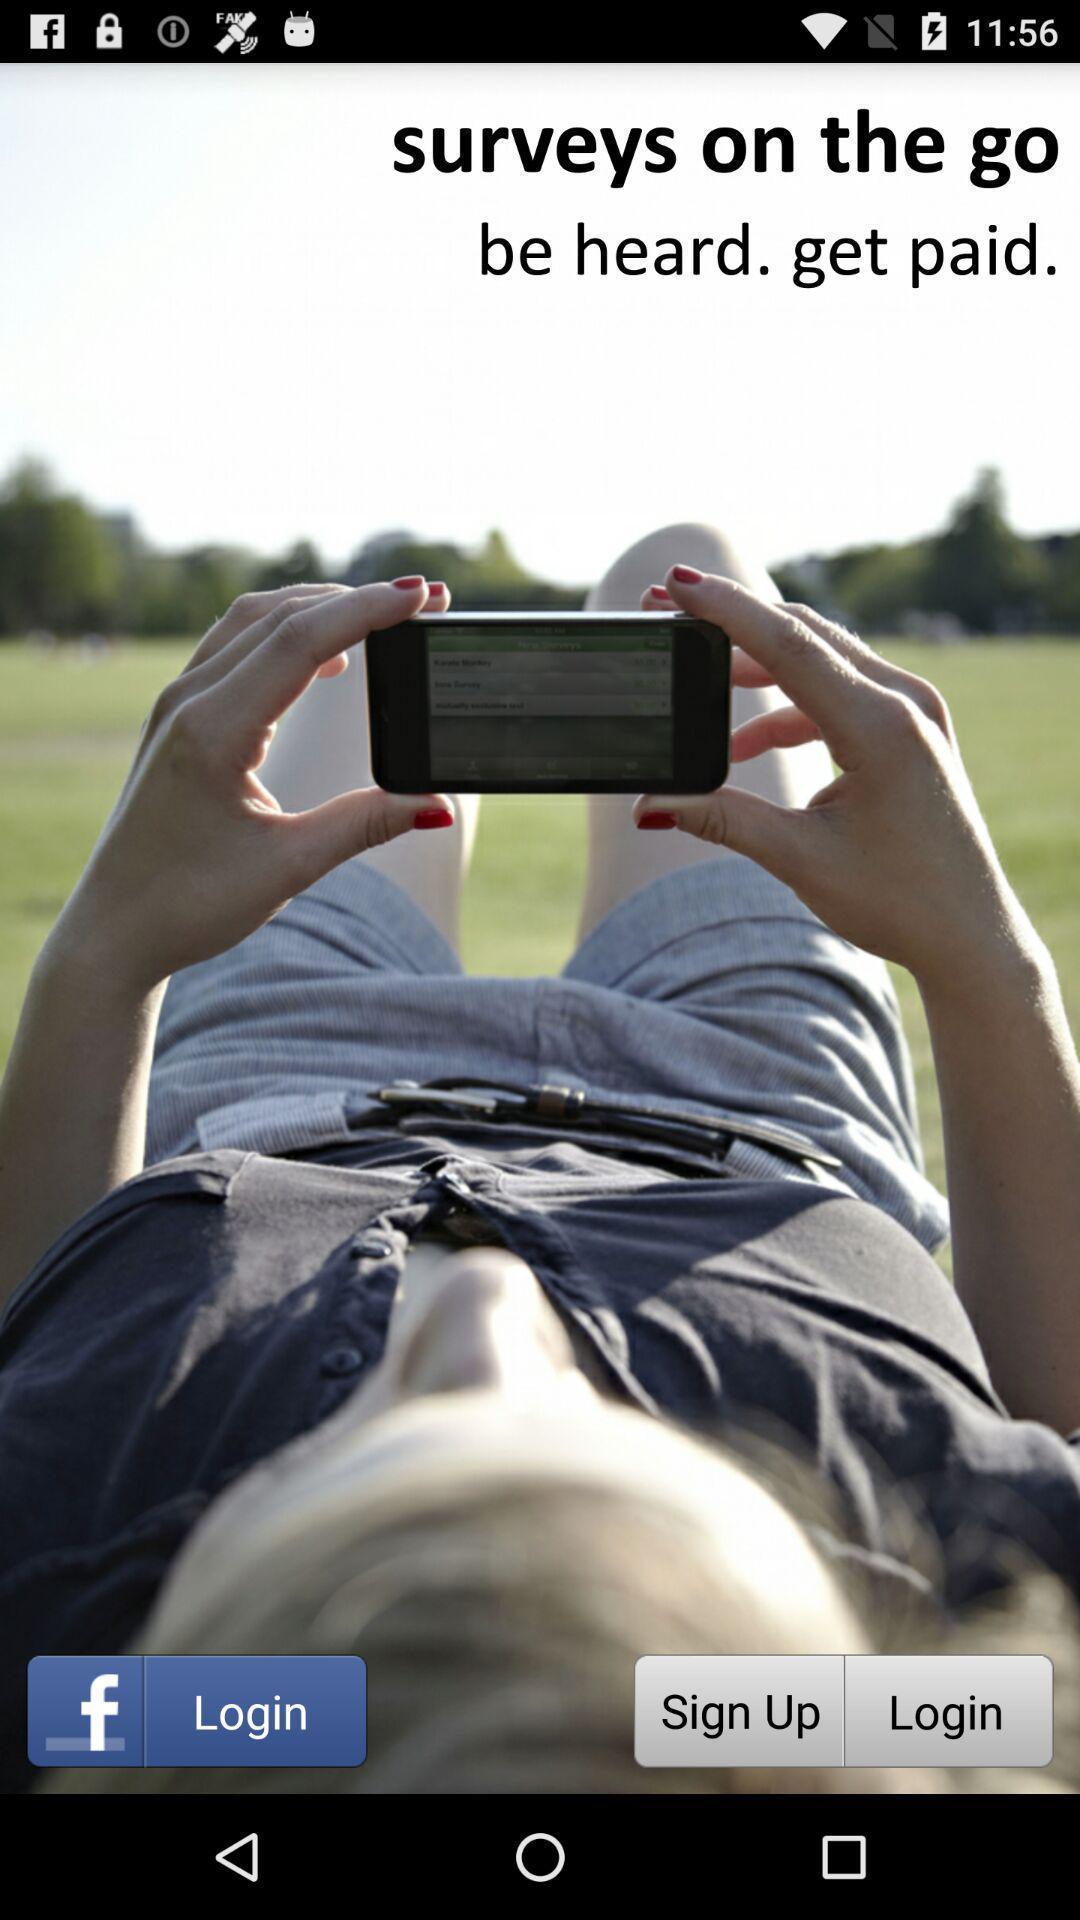What can you discern from this picture? Welcome and log-in page for an application. 